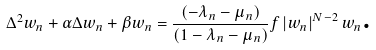<formula> <loc_0><loc_0><loc_500><loc_500>\Delta ^ { 2 } w _ { n } + \alpha \Delta w _ { n } + \beta w _ { n } = \frac { \left ( - \lambda _ { n } - \mu _ { n } \right ) } { \left ( 1 - \lambda _ { n } - \mu _ { n } \right ) } f \left | w _ { n } \right | ^ { N - 2 } w _ { n } \text {.}</formula> 